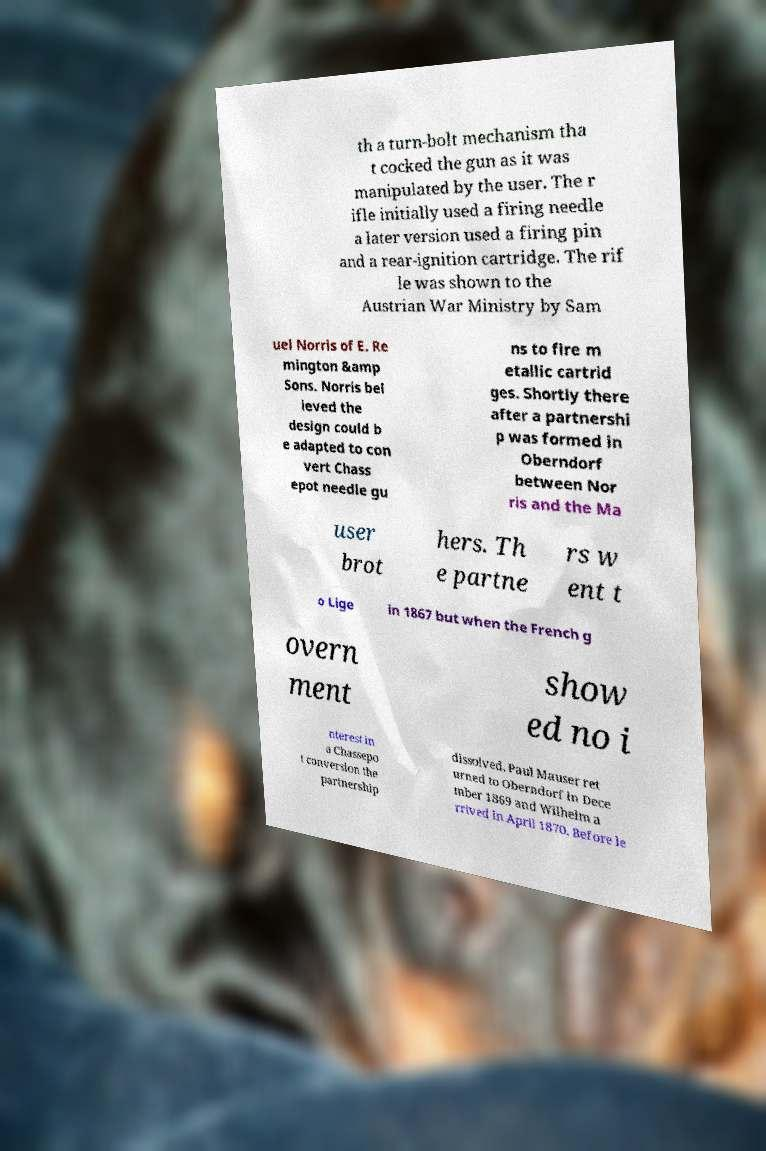Please read and relay the text visible in this image. What does it say? th a turn-bolt mechanism tha t cocked the gun as it was manipulated by the user. The r ifle initially used a firing needle a later version used a firing pin and a rear-ignition cartridge. The rif le was shown to the Austrian War Ministry by Sam uel Norris of E. Re mington &amp Sons. Norris bel ieved the design could b e adapted to con vert Chass epot needle gu ns to fire m etallic cartrid ges. Shortly there after a partnershi p was formed in Oberndorf between Nor ris and the Ma user brot hers. Th e partne rs w ent t o Lige in 1867 but when the French g overn ment show ed no i nterest in a Chassepo t conversion the partnership dissolved. Paul Mauser ret urned to Oberndorf in Dece mber 1869 and Wilhelm a rrived in April 1870. Before le 